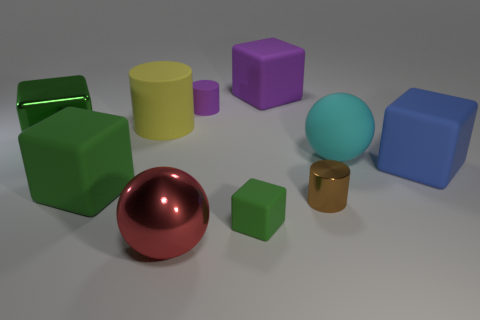How many blocks are large green shiny things or big green matte things?
Offer a very short reply. 2. There is a matte block that is the same size as the purple cylinder; what color is it?
Provide a short and direct response. Green. There is a small matte object in front of the rubber object that is right of the matte ball; are there any things in front of it?
Provide a succinct answer. Yes. What size is the brown cylinder?
Give a very brief answer. Small. How many objects are big objects or red things?
Ensure brevity in your answer.  7. There is a small cylinder that is the same material as the cyan sphere; what color is it?
Provide a short and direct response. Purple. Do the thing that is behind the purple cylinder and the tiny green object have the same shape?
Your response must be concise. Yes. How many objects are big cubes that are behind the matte ball or small cylinders that are left of the tiny brown cylinder?
Provide a succinct answer. 3. What color is the big matte object that is the same shape as the tiny metallic object?
Your answer should be compact. Yellow. Is the shape of the tiny purple thing the same as the big yellow object that is behind the big cyan matte sphere?
Ensure brevity in your answer.  Yes. 